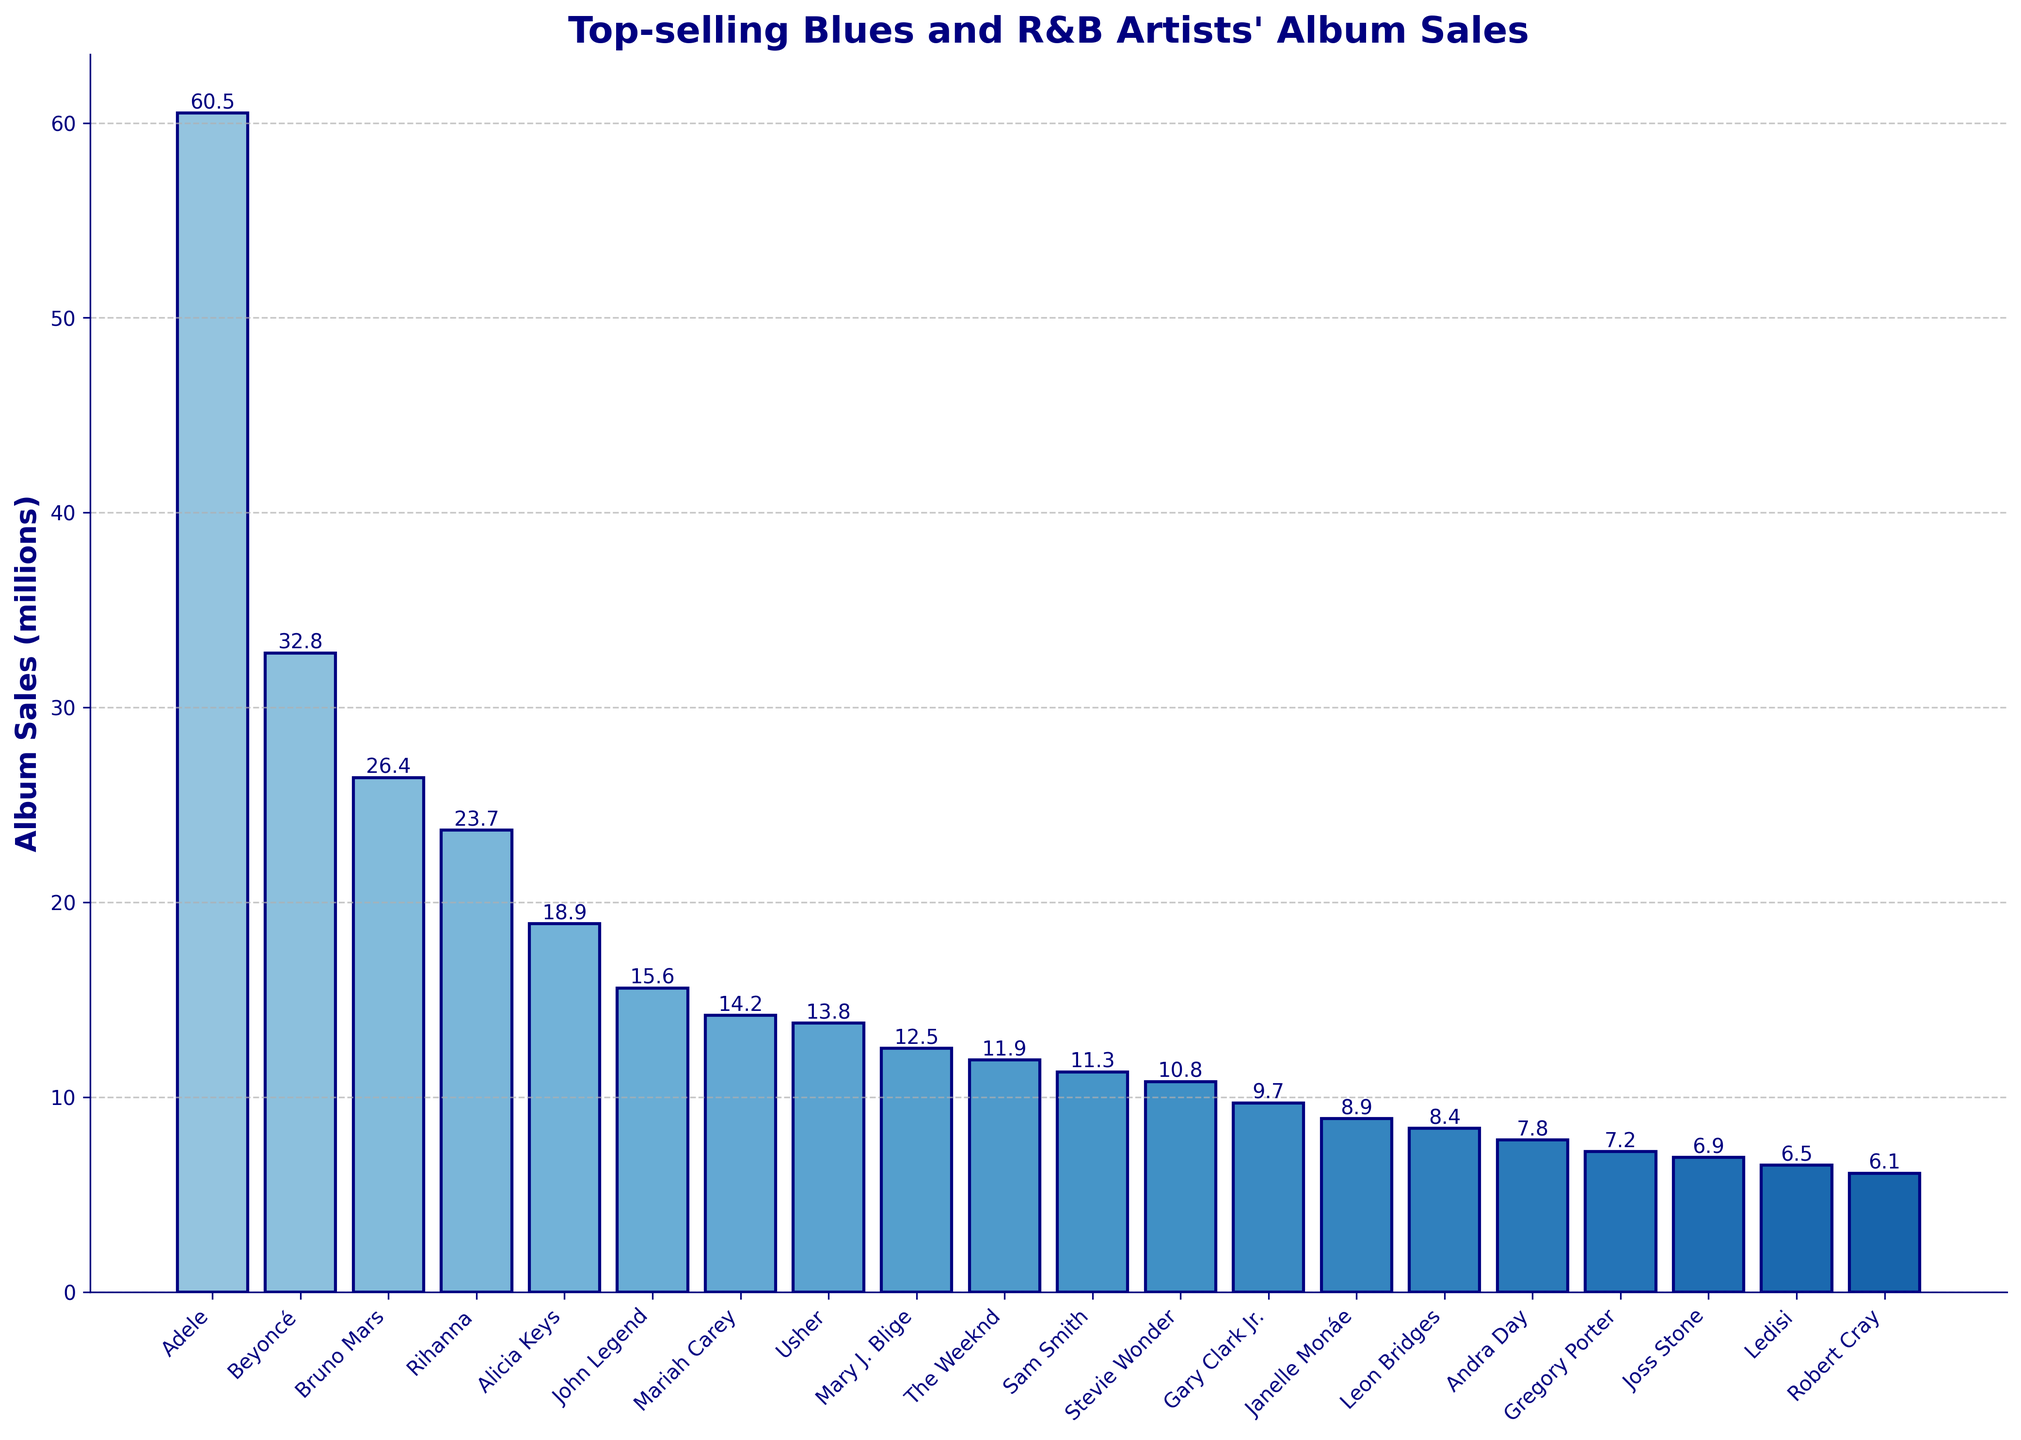What's the total album sales of the top three artists? Add the sales of Adele, Beyoncé, and Bruno Mars. (60.5 + 32.8 + 26.4) = 119.7 million
Answer: 119.7 million Which artist has the smallest album sales, and how much is it? Look for the shortest bar. Robert Cray has the smallest album sales, which is 6.1 million.
Answer: Robert Cray, 6.1 million How much more did Adele sell than Beyoncé? Subtract Beyoncé's sales from Adele's sales. (60.5 - 32.8) = 27.7 million
Answer: 27.7 million Rank the fifth highest selling artist's album sales. Identify the artist and their sales; Alicia Keys has the fifth highest sales with 18.9 million.
Answer: Alicia Keys, 18.9 million What is the combined album sales of artists selling less than 10 million? Add the sales of Gary Clark Jr., Janelle Monáe, Leon Bridges, Andra Day, Gregory Porter, Joss Stone, Ledisi, and Robert Cray. (9.7 + 8.9 + 8.4 + 7.8 + 7.2 + 6.9 + 6.5 + 6.1) = 61.5 million
Answer: 61.5 million How many artists have album sales above 20 million? Count the bars with heights above 20 million. Adele, Beyoncé, Bruno Mars, and Rihanna meet this criterion.
Answer: 4 Who is ranked just below Mariah Carey in album sales? Identify the artist below Mariah Carey's bar. Usher is directly below Mariah Carey.
Answer: Usher What is the average album sales of the top five artists? Sum the sales of the top five artists and divide by 5. (60.5 + 32.8 + 26.4 + 23.7 + 18.9) = 162.3, then 162.3 / 5 = 32.46 million
Answer: 32.46 million Which artist has approximately double the album sales of John Legend? John Legend's sales are 15.6 million. Look for an artist with approximately 31.2 million sales. Beyoncé (32.8 million) is the closest.
Answer: Beyoncé How much more Jessica Stone has sold than Ledisi? Jessica Stone sold 6.9 million and Ledisi sold 6.5 million. Subtract Ledisi's sales from Jessica Stone's. (6.9 - 6.5) = 0.4 million
Answer: 0.4 million 